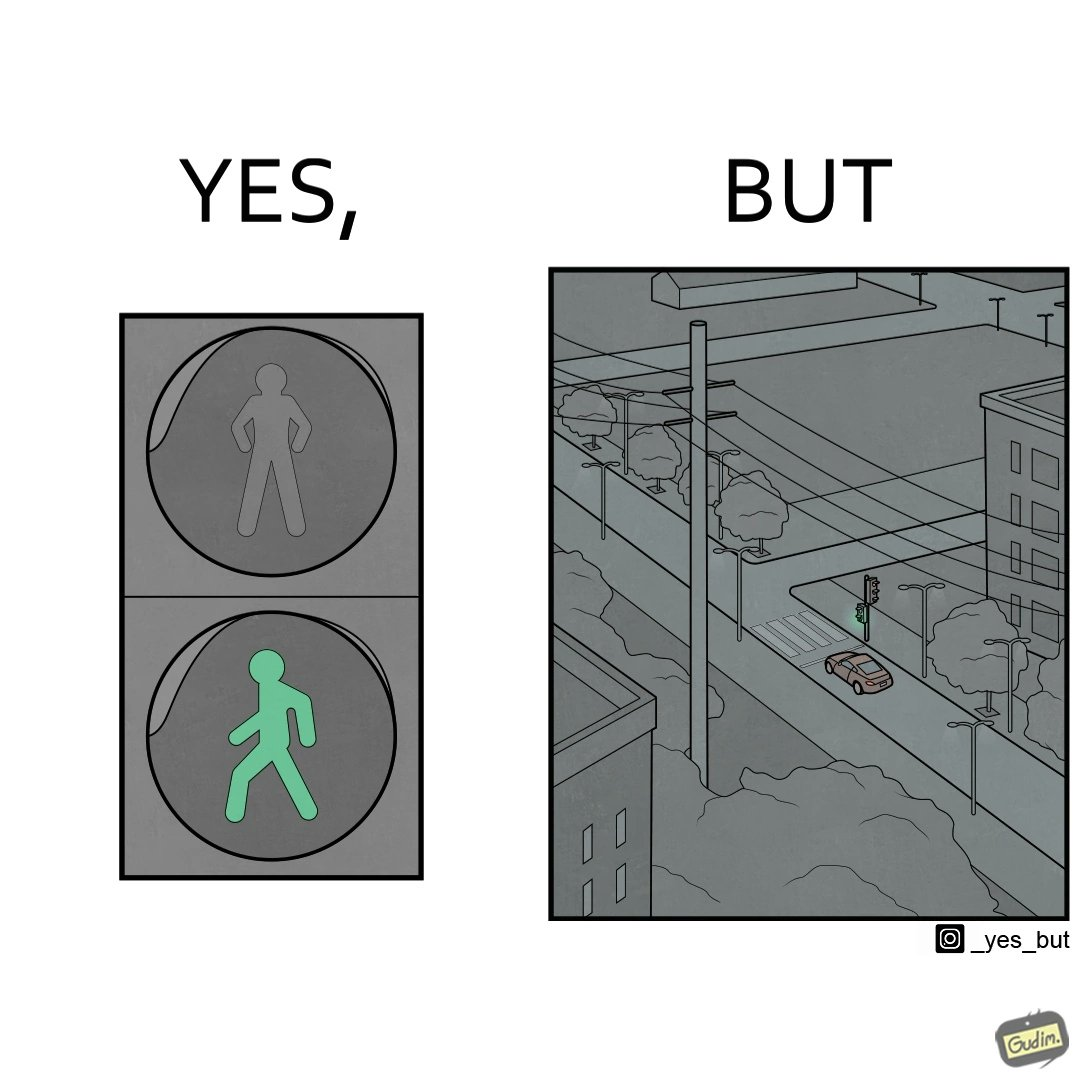What do you see in each half of this image? In the left part of the image: The image shows the walk sign turned to green on a traffic signal. In the right part of the image: The image shows an empty road with only one car on the road. The car is waiting for the walk sign to turn to red so that it can cross the zebra crossing.  There is no one else on the road except from the car. 